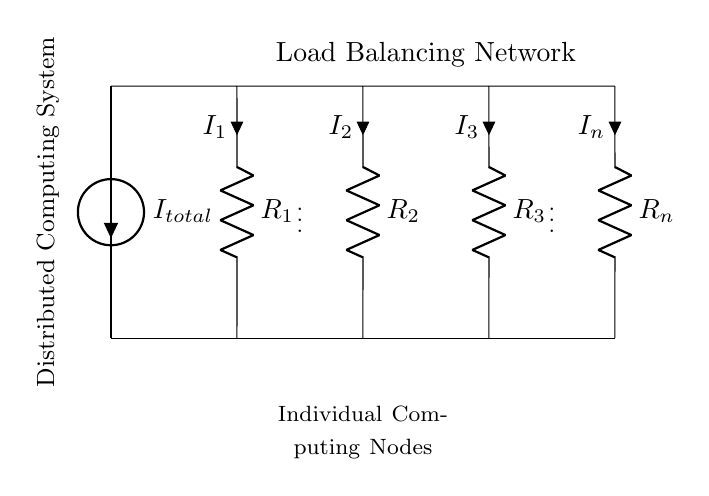What is the total current entering the circuit? The total current entering the circuit is denoted as I total, which is the current source in the diagram.
Answer: I total What does the circuit represent? This circuit represents a load balancing network for a distributed computing system by showing how the total current is divided among the different resistors representing computing nodes.
Answer: Load balancing network How many resistors are present in the circuit? The circuit shows four resistors, labeled R1, R2, R3, and Rn, which split the total current into multiple paths.
Answer: Four If R1 is twice the value of R2, which path has more current? Since R1 is twice the value of R2, by Ohm's law, the lower resistance (R2) will have a higher current flowing through it due to the inverse relationship of resistance and current in a parallel circuit.
Answer: R2 What component is used to visualize the current in each branch? The components labeled i with arrows indicate the direction and magnitude of the current flowing through each resistor.
Answer: Current labels (i) How does current divide among the resistors? The total current divides among the resistors inversely proportional to their resistances; lower resistance loads draw more current.
Answer: Inversely proportional to resistance What is the role of the current source labeled I total? The current source labeled I total provides the entire current that is being distributed across various paths of the circuit through the resistors.
Answer: Supply total current 